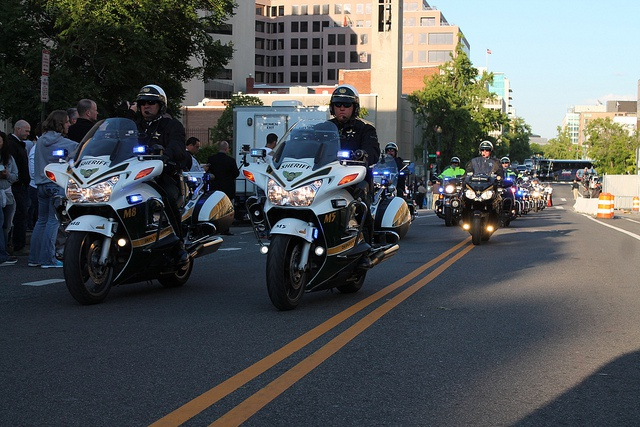Describe the objects in this image and their specific colors. I can see motorcycle in black, lightblue, navy, and gray tones, motorcycle in black, navy, lightblue, and gray tones, people in black, navy, gray, and blue tones, people in black, gray, and darkgray tones, and people in black, navy, darkblue, and gray tones in this image. 